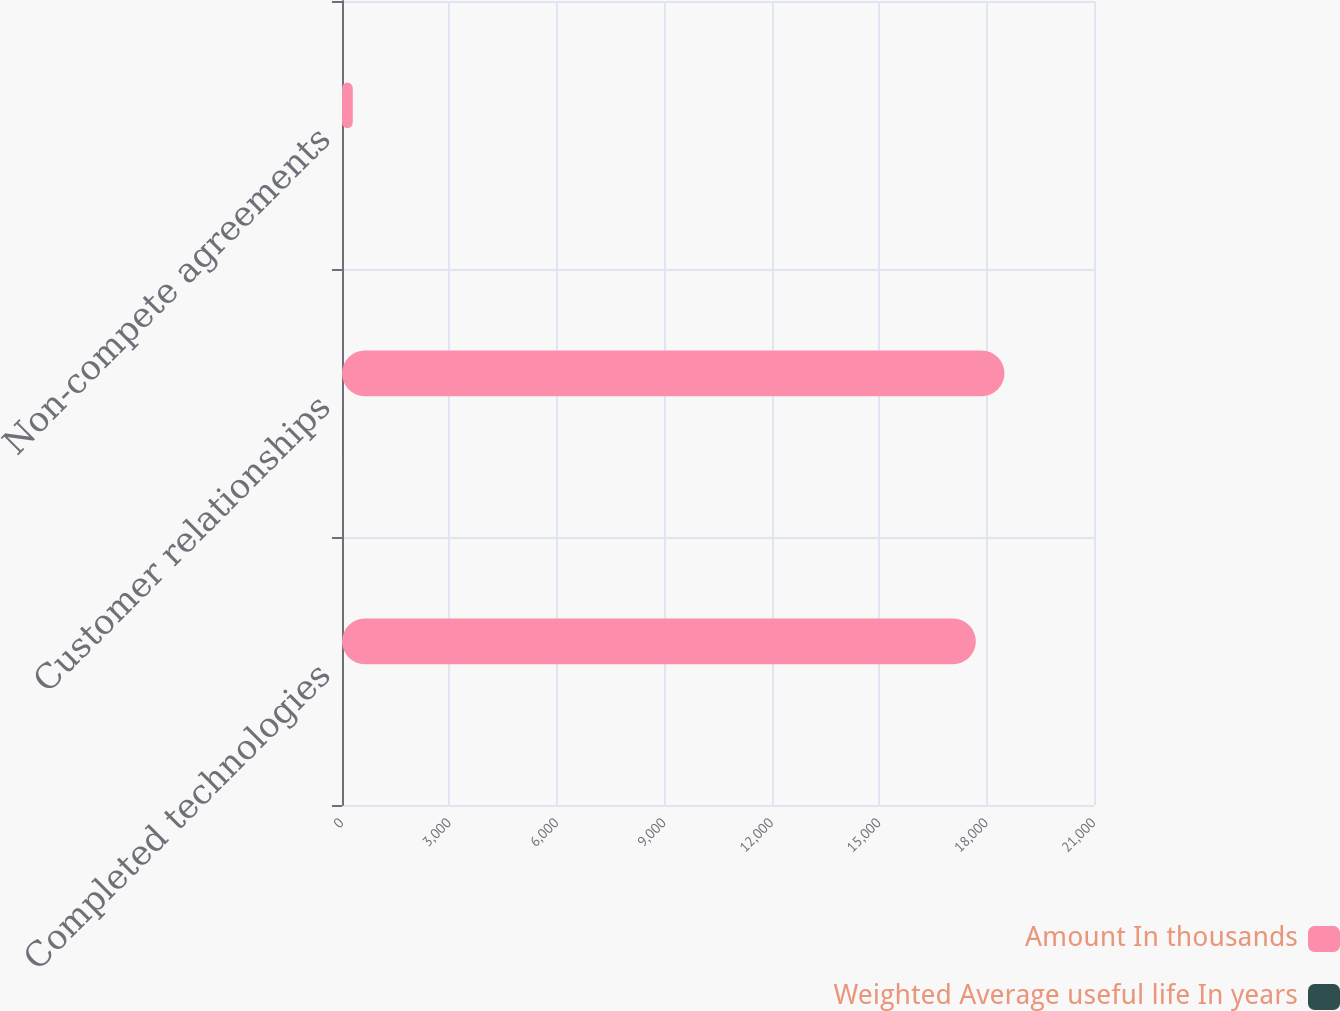<chart> <loc_0><loc_0><loc_500><loc_500><stacked_bar_chart><ecel><fcel>Completed technologies<fcel>Customer relationships<fcel>Non-compete agreements<nl><fcel>Amount In thousands<fcel>17700<fcel>18500<fcel>300<nl><fcel>Weighted Average useful life In years<fcel>4.4<fcel>5.9<fcel>2.5<nl></chart> 